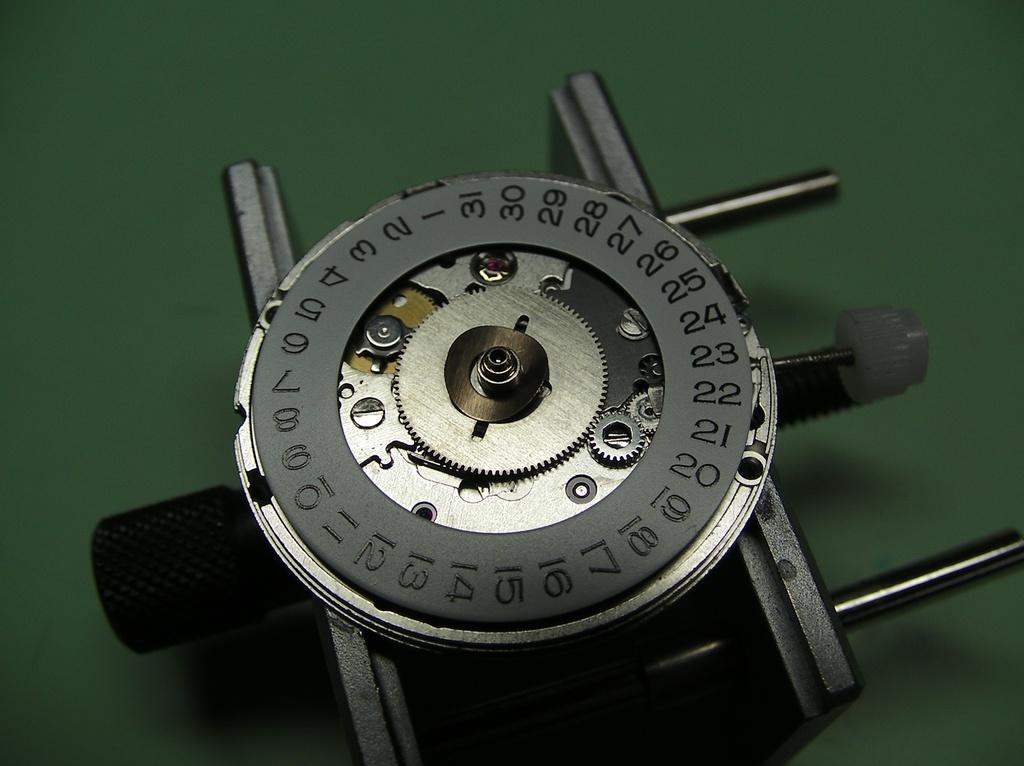Provide a one-sentence caption for the provided image. A round mechanism numbered one to thirty one laying on a green surface. 